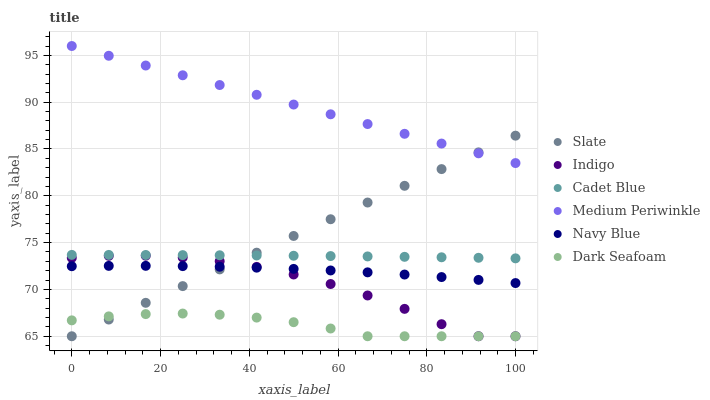Does Dark Seafoam have the minimum area under the curve?
Answer yes or no. Yes. Does Medium Periwinkle have the maximum area under the curve?
Answer yes or no. Yes. Does Indigo have the minimum area under the curve?
Answer yes or no. No. Does Indigo have the maximum area under the curve?
Answer yes or no. No. Is Medium Periwinkle the smoothest?
Answer yes or no. Yes. Is Indigo the roughest?
Answer yes or no. Yes. Is Navy Blue the smoothest?
Answer yes or no. No. Is Navy Blue the roughest?
Answer yes or no. No. Does Indigo have the lowest value?
Answer yes or no. Yes. Does Navy Blue have the lowest value?
Answer yes or no. No. Does Medium Periwinkle have the highest value?
Answer yes or no. Yes. Does Indigo have the highest value?
Answer yes or no. No. Is Dark Seafoam less than Cadet Blue?
Answer yes or no. Yes. Is Medium Periwinkle greater than Dark Seafoam?
Answer yes or no. Yes. Does Slate intersect Navy Blue?
Answer yes or no. Yes. Is Slate less than Navy Blue?
Answer yes or no. No. Is Slate greater than Navy Blue?
Answer yes or no. No. Does Dark Seafoam intersect Cadet Blue?
Answer yes or no. No. 